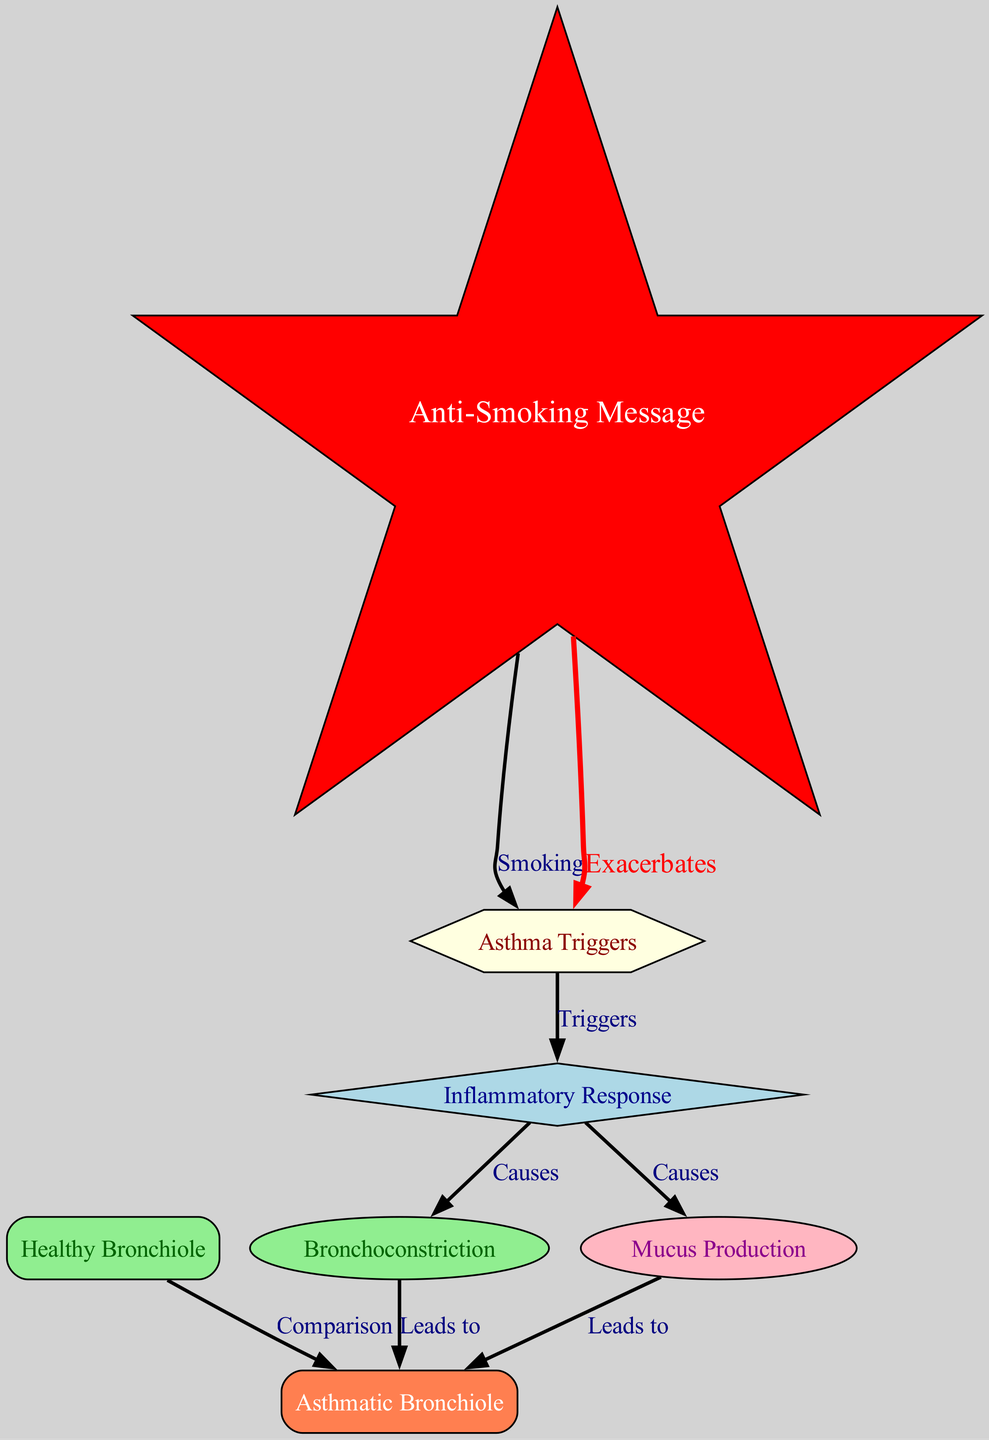What are common asthma triggers? The diagram identifies "Asthma Triggers" as a node, but specific triggers are not listed. However, it typically includes allergens, exercise, and respiratory infections.
Answer: Asthma Triggers How many nodes are in the diagram? The diagram contains 7 nodes that represent various elements involved in the pathophysiology of asthma.
Answer: 7 What leads to bronchoconstriction? According to the diagram, bronchoconstriction is caused by the "Inflammatory Response," which manifests as a reaction to asthma triggers.
Answer: Inflammatory Response What node compares the asthmatic and healthy bronchioles? The diagram includes a comparison between "Asthmatic Bronchiole" and "Healthy Bronchiole," highlighting the differences due to inflammation and mucus production in asthma.
Answer: Comparison What exacerbates asthma triggers? The diagram specifically indicates that smoking exacerbates asthma triggers, which is emphasized with a red edge labeled "Exacerbates."
Answer: Smoking How do asthma triggers affect mucus production? The diagram indicates a direct relationship where asthma triggers lead to an "Inflammatory Response," which in turn causes "Mucus Production," establishing a pathway from trigger to effect.
Answer: Mucus Production Which node has the anti-smoking message? The anti-smoking message is represented by the node labeled "Anti-Smoking Message," which is depicted as a star in the diagram.
Answer: Anti-Smoking Message What color represents the healthy bronchiole? The "Healthy Bronchiole" node is highlighted in light green, indicating its distinction from the asthmatic counterpart.
Answer: Light green 